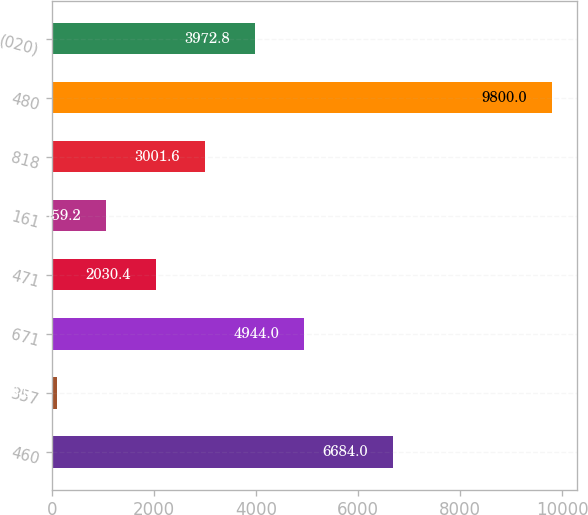Convert chart to OTSL. <chart><loc_0><loc_0><loc_500><loc_500><bar_chart><fcel>460<fcel>357<fcel>671<fcel>471<fcel>161<fcel>818<fcel>480<fcel>(020)<nl><fcel>6684<fcel>88<fcel>4944<fcel>2030.4<fcel>1059.2<fcel>3001.6<fcel>9800<fcel>3972.8<nl></chart> 